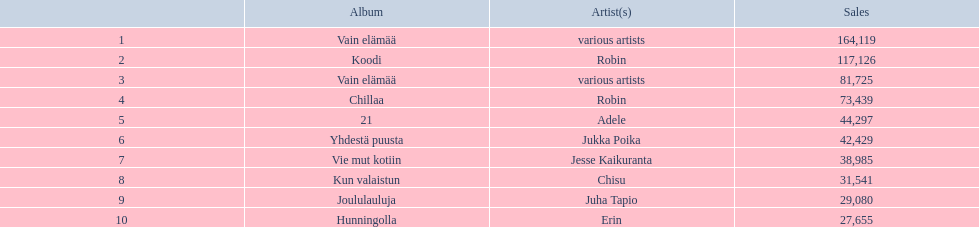Which musical compilation has the highest sales figures but lacks a designated performer? Vain elämää. 